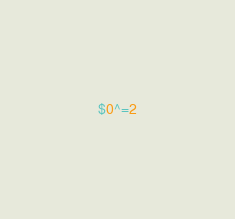Convert code to text. <code><loc_0><loc_0><loc_500><loc_500><_Awk_>$0^=2
</code> 